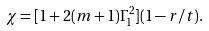<formula> <loc_0><loc_0><loc_500><loc_500>\chi = [ 1 + 2 ( m + 1 ) \Gamma _ { 1 } ^ { 2 } ] ( 1 - r / t ) .</formula> 